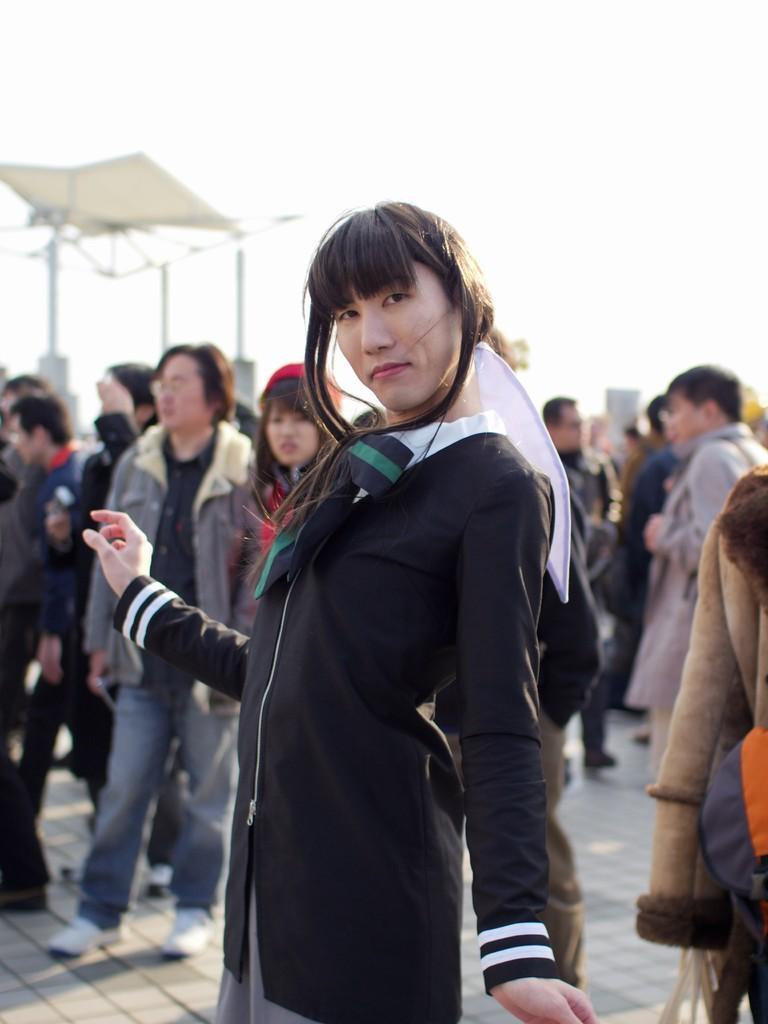How would you summarize this image in a sentence or two? In the image we can see there are many people wearing clothes, this is a footpath and a sky, this person is wearing a red color cap. 